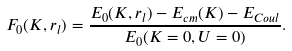<formula> <loc_0><loc_0><loc_500><loc_500>F _ { 0 } ( { K } , r _ { l } ) = \frac { E _ { 0 } ( { K } , r _ { l } ) - E _ { c m } ( { K } ) - E _ { C o u l } } { E _ { 0 } ( { K } = 0 , U = 0 ) } .</formula> 